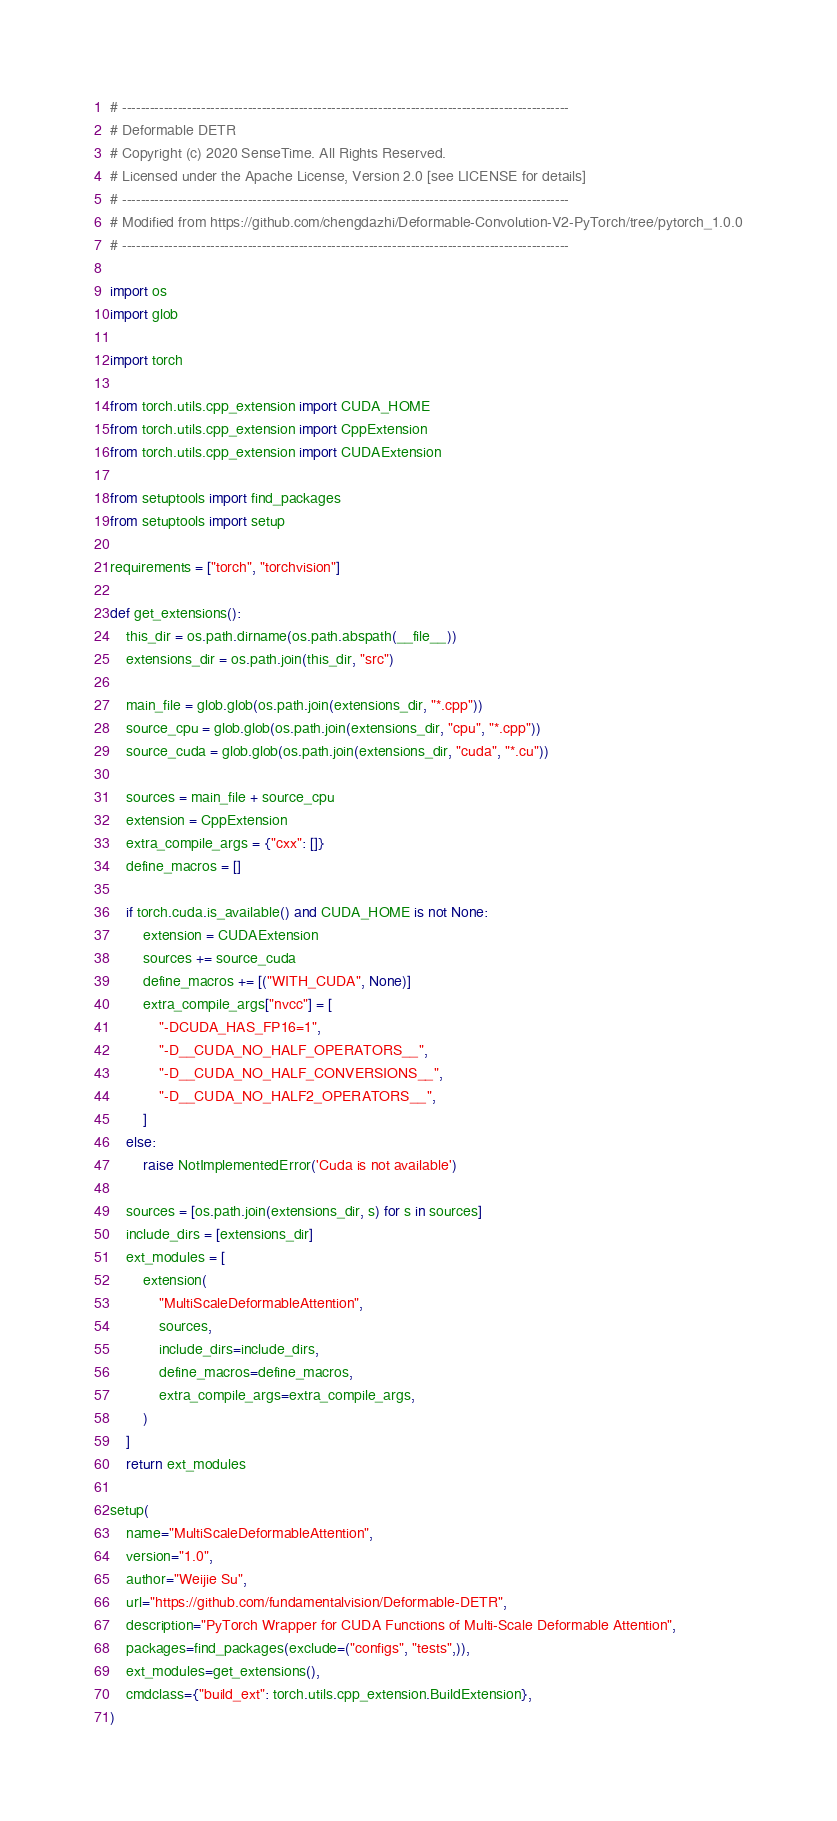<code> <loc_0><loc_0><loc_500><loc_500><_Python_># ------------------------------------------------------------------------------------------------
# Deformable DETR
# Copyright (c) 2020 SenseTime. All Rights Reserved.
# Licensed under the Apache License, Version 2.0 [see LICENSE for details]
# ------------------------------------------------------------------------------------------------
# Modified from https://github.com/chengdazhi/Deformable-Convolution-V2-PyTorch/tree/pytorch_1.0.0
# ------------------------------------------------------------------------------------------------

import os
import glob

import torch

from torch.utils.cpp_extension import CUDA_HOME
from torch.utils.cpp_extension import CppExtension
from torch.utils.cpp_extension import CUDAExtension

from setuptools import find_packages
from setuptools import setup

requirements = ["torch", "torchvision"]

def get_extensions():
    this_dir = os.path.dirname(os.path.abspath(__file__))
    extensions_dir = os.path.join(this_dir, "src")

    main_file = glob.glob(os.path.join(extensions_dir, "*.cpp"))
    source_cpu = glob.glob(os.path.join(extensions_dir, "cpu", "*.cpp"))
    source_cuda = glob.glob(os.path.join(extensions_dir, "cuda", "*.cu"))

    sources = main_file + source_cpu
    extension = CppExtension
    extra_compile_args = {"cxx": []}
    define_macros = []

    if torch.cuda.is_available() and CUDA_HOME is not None:
        extension = CUDAExtension
        sources += source_cuda
        define_macros += [("WITH_CUDA", None)]
        extra_compile_args["nvcc"] = [
            "-DCUDA_HAS_FP16=1",
            "-D__CUDA_NO_HALF_OPERATORS__",
            "-D__CUDA_NO_HALF_CONVERSIONS__",
            "-D__CUDA_NO_HALF2_OPERATORS__",
        ]
    else:
        raise NotImplementedError('Cuda is not available')

    sources = [os.path.join(extensions_dir, s) for s in sources]
    include_dirs = [extensions_dir]
    ext_modules = [
        extension(
            "MultiScaleDeformableAttention",
            sources,
            include_dirs=include_dirs,
            define_macros=define_macros,
            extra_compile_args=extra_compile_args,
        )
    ]
    return ext_modules

setup(
    name="MultiScaleDeformableAttention",
    version="1.0",
    author="Weijie Su",
    url="https://github.com/fundamentalvision/Deformable-DETR",
    description="PyTorch Wrapper for CUDA Functions of Multi-Scale Deformable Attention",
    packages=find_packages(exclude=("configs", "tests",)),
    ext_modules=get_extensions(),
    cmdclass={"build_ext": torch.utils.cpp_extension.BuildExtension},
)
</code> 